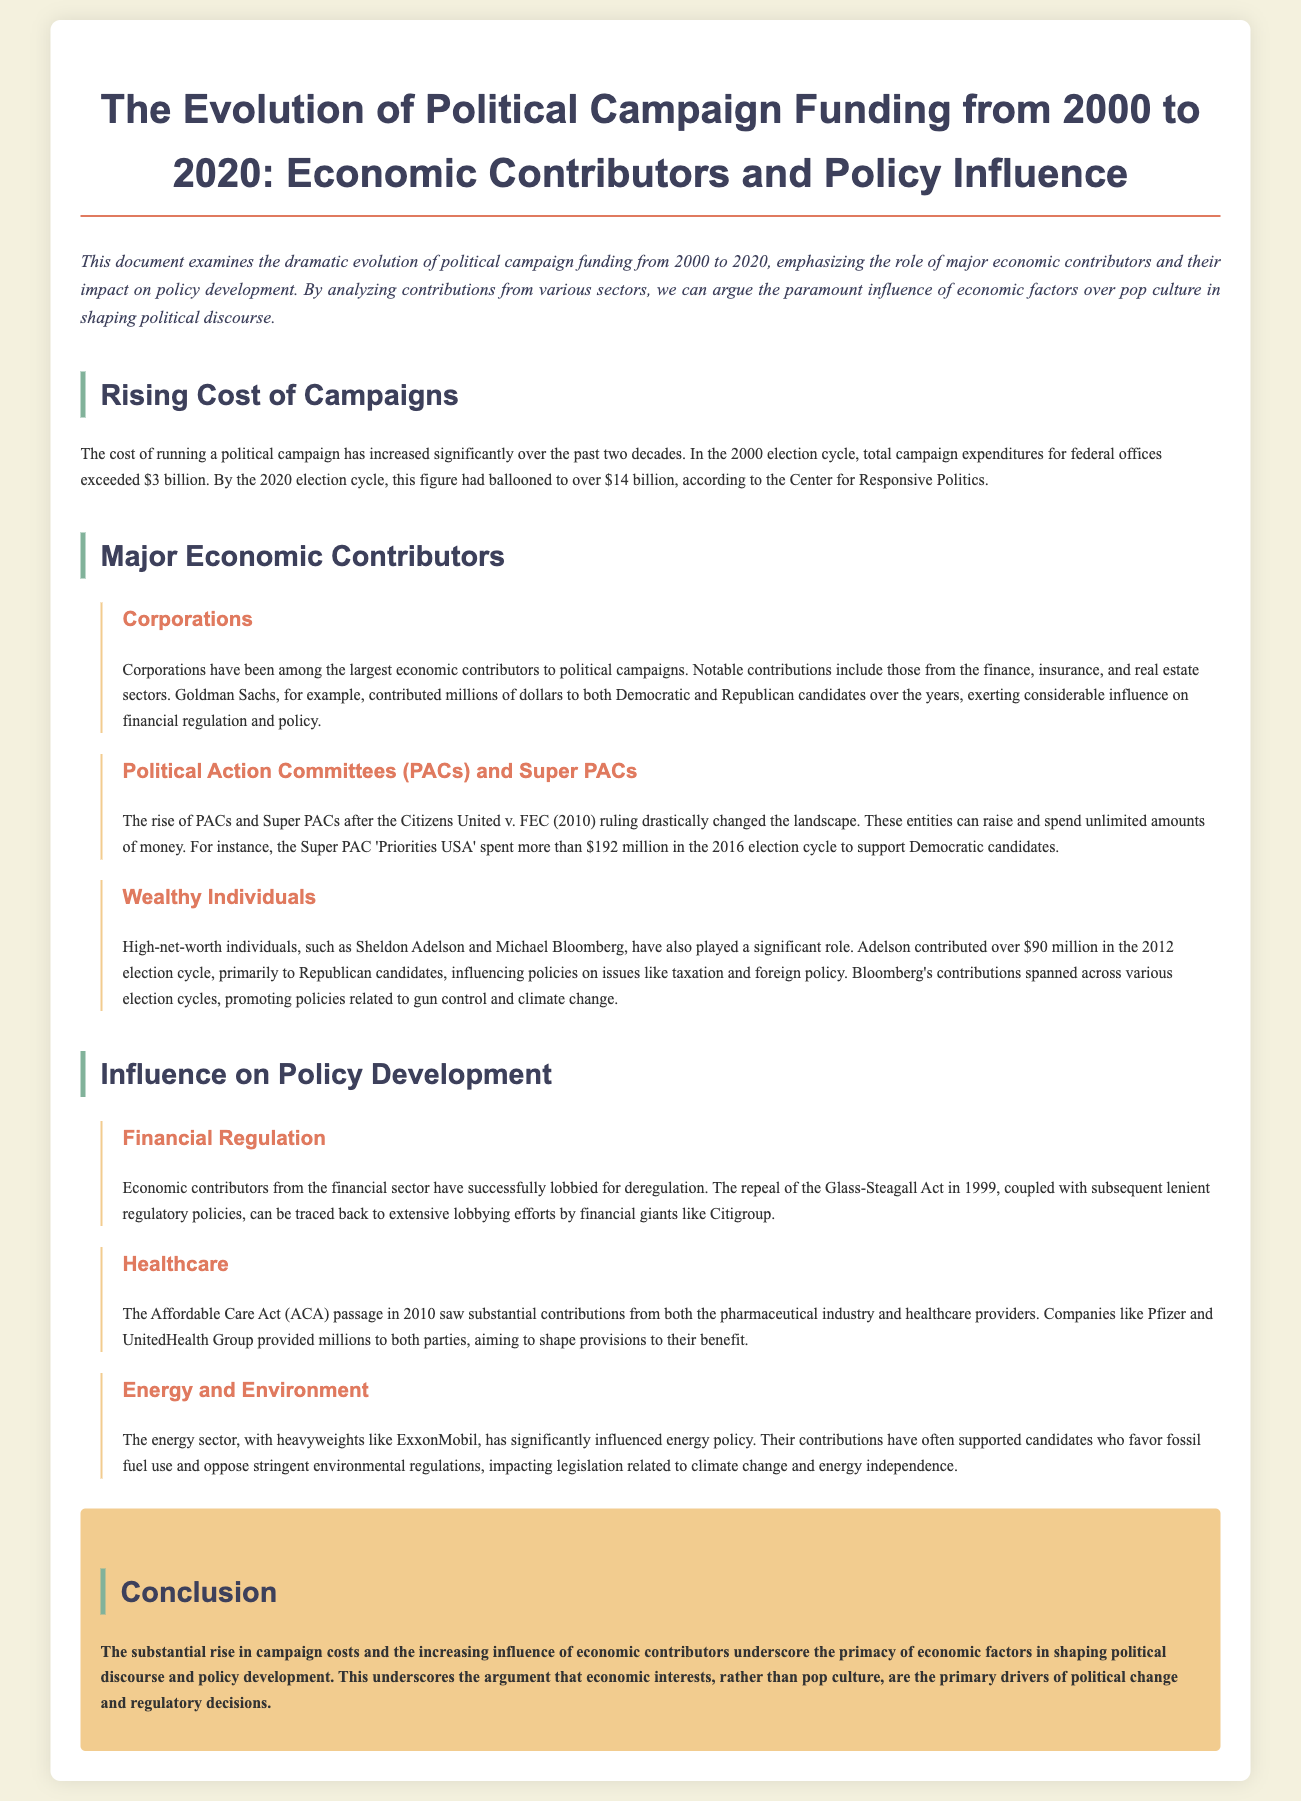What was the total campaign expenditure for federal offices in the 2000 election cycle? The document states that in the 2000 election cycle, total campaign expenditures for federal offices exceeded $3 billion.
Answer: $3 billion What major court ruling influenced the rise of PACs and Super PACs? The rise of PACs and Super PACs was influenced by the Citizens United v. FEC ruling in 2010.
Answer: Citizens United v. FEC Which industry contributed substantially to the Affordable Care Act? The pharmaceutical industry significantly contributed to the passage of the Affordable Care Act.
Answer: Pharmaceutical industry Who provided over $90 million in contributions in the 2012 election cycle? Sheldon Adelson contributed over $90 million in the 2012 election cycle.
Answer: Sheldon Adelson What is the main argument presented in the conclusion? The conclusion argues that economic interests are the primary drivers of political change and regulatory decisions.
Answer: Economic interests are primary drivers What sector's contributions have significantly influenced energy policy? The energy sector's contributions, especially from ExxonMobil, have significantly influenced energy policy.
Answer: Energy sector How much did the Super PAC 'Priorities USA' spend in the 2016 election cycle? Priorities USA spent more than $192 million in the 2016 election cycle to support Democratic candidates.
Answer: $192 million What significant act was repealed in connection with lobbying by financial giants? The repeal of the Glass-Steagall Act is connected to extensive lobbying efforts by financial giants.
Answer: Glass-Steagall Act Which two sectors were highlighted for their influence on policy related to taxation and foreign policy? Contributions from wealthy individuals like Sheldon Adelson and Michael Bloomberg have influenced policies related to taxation and foreign policy.
Answer: Taxation and foreign policy 